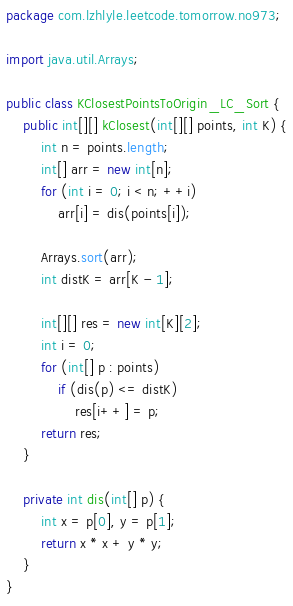Convert code to text. <code><loc_0><loc_0><loc_500><loc_500><_Java_>package com.lzhlyle.leetcode.tomorrow.no973;

import java.util.Arrays;

public class KClosestPointsToOrigin_LC_Sort {
    public int[][] kClosest(int[][] points, int K) {
        int n = points.length;
        int[] arr = new int[n];
        for (int i = 0; i < n; ++i)
            arr[i] = dis(points[i]);

        Arrays.sort(arr);
        int distK = arr[K - 1];

        int[][] res = new int[K][2];
        int i = 0;
        for (int[] p : points)
            if (dis(p) <= distK)
                res[i++] = p;
        return res;
    }

    private int dis(int[] p) {
        int x = p[0], y = p[1];
        return x * x + y * y;
    }
}
</code> 